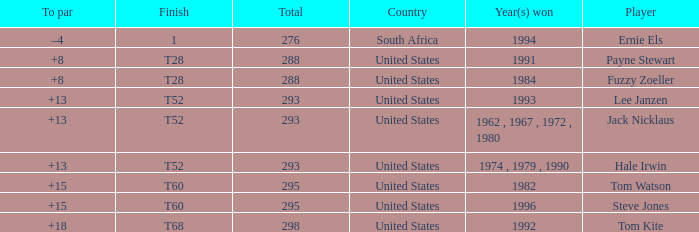Who is the player who won in 1994? Ernie Els. 